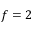<formula> <loc_0><loc_0><loc_500><loc_500>f = 2</formula> 